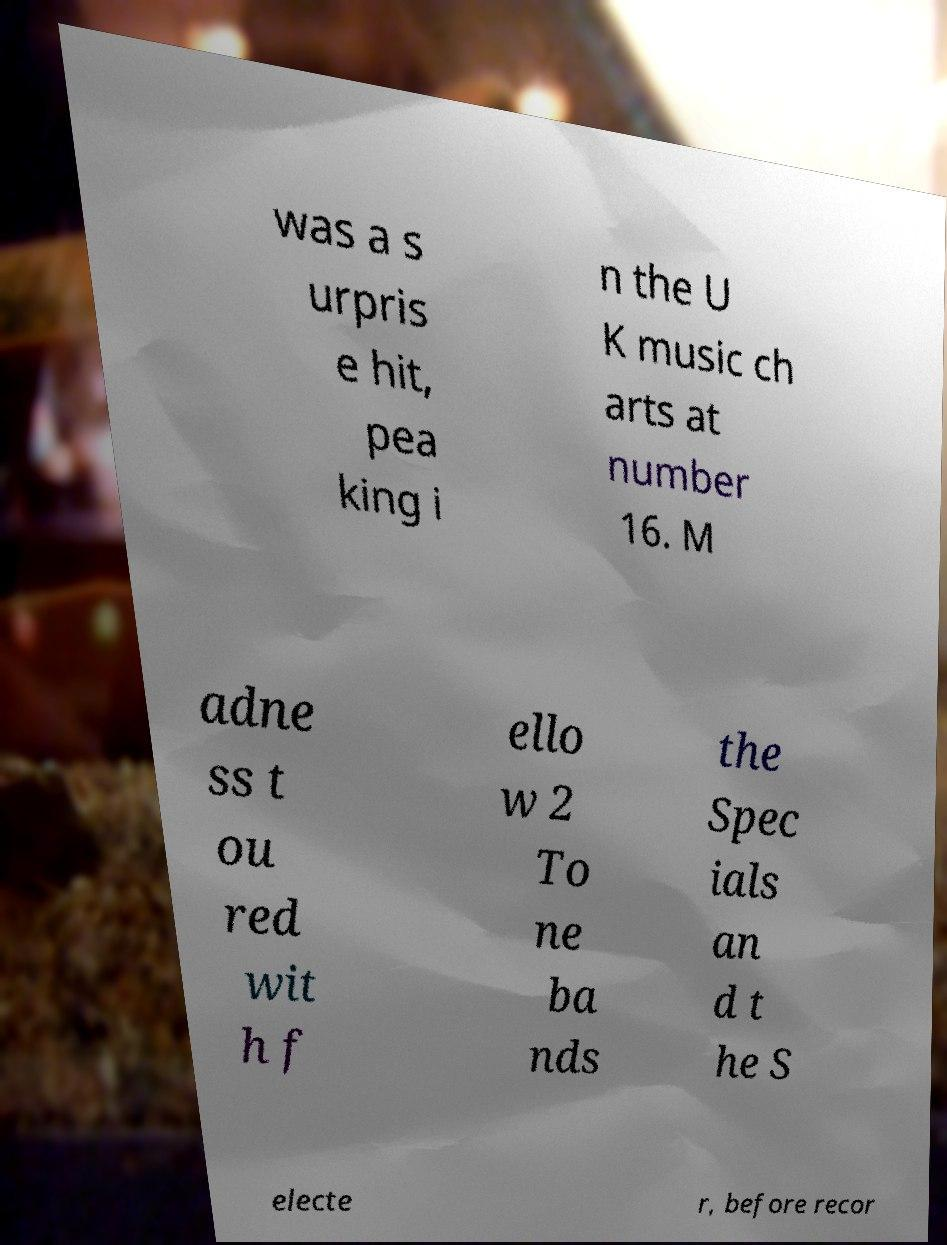There's text embedded in this image that I need extracted. Can you transcribe it verbatim? was a s urpris e hit, pea king i n the U K music ch arts at number 16. M adne ss t ou red wit h f ello w 2 To ne ba nds the Spec ials an d t he S electe r, before recor 